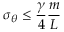<formula> <loc_0><loc_0><loc_500><loc_500>\sigma _ { \theta } \leq \frac { \gamma } { 4 } \frac { m } { L }</formula> 